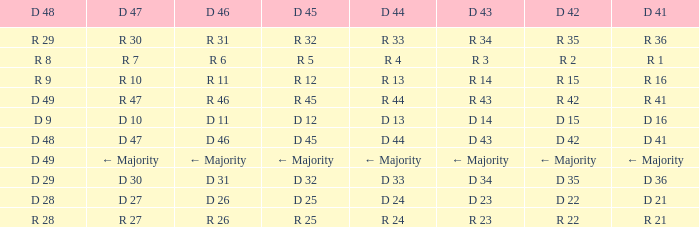Name the D 47 when it has a D 41 of r 36 R 30. 